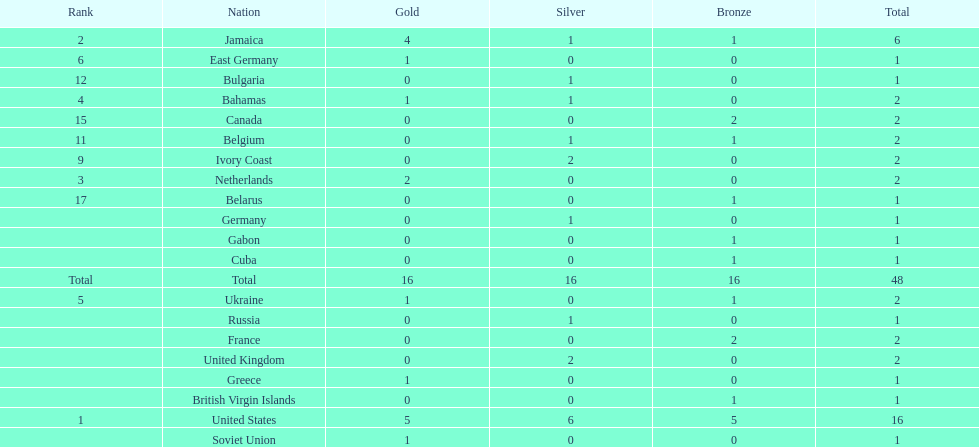What country won more gold medals than any other? United States. 